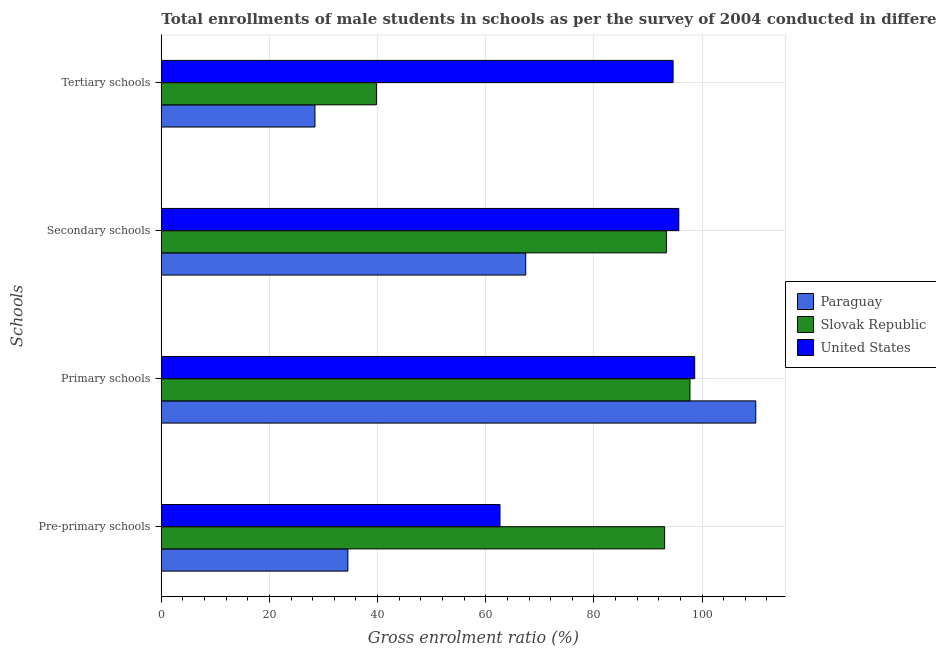How many groups of bars are there?
Offer a terse response. 4. What is the label of the 4th group of bars from the top?
Ensure brevity in your answer.  Pre-primary schools. What is the gross enrolment ratio(male) in pre-primary schools in Slovak Republic?
Your answer should be very brief. 93.08. Across all countries, what is the maximum gross enrolment ratio(male) in secondary schools?
Provide a succinct answer. 95.7. Across all countries, what is the minimum gross enrolment ratio(male) in primary schools?
Ensure brevity in your answer.  97.76. In which country was the gross enrolment ratio(male) in primary schools maximum?
Your answer should be compact. Paraguay. In which country was the gross enrolment ratio(male) in secondary schools minimum?
Make the answer very short. Paraguay. What is the total gross enrolment ratio(male) in tertiary schools in the graph?
Your response must be concise. 162.84. What is the difference between the gross enrolment ratio(male) in secondary schools in Slovak Republic and that in United States?
Keep it short and to the point. -2.29. What is the difference between the gross enrolment ratio(male) in primary schools in Slovak Republic and the gross enrolment ratio(male) in tertiary schools in Paraguay?
Provide a succinct answer. 69.35. What is the average gross enrolment ratio(male) in secondary schools per country?
Offer a very short reply. 85.5. What is the difference between the gross enrolment ratio(male) in primary schools and gross enrolment ratio(male) in secondary schools in Paraguay?
Your answer should be very brief. 42.54. In how many countries, is the gross enrolment ratio(male) in pre-primary schools greater than 48 %?
Ensure brevity in your answer.  2. What is the ratio of the gross enrolment ratio(male) in pre-primary schools in Paraguay to that in United States?
Your response must be concise. 0.55. Is the gross enrolment ratio(male) in tertiary schools in Slovak Republic less than that in United States?
Provide a short and direct response. Yes. Is the difference between the gross enrolment ratio(male) in secondary schools in Paraguay and Slovak Republic greater than the difference between the gross enrolment ratio(male) in primary schools in Paraguay and Slovak Republic?
Offer a terse response. No. What is the difference between the highest and the second highest gross enrolment ratio(male) in pre-primary schools?
Provide a short and direct response. 30.44. What is the difference between the highest and the lowest gross enrolment ratio(male) in secondary schools?
Your answer should be compact. 28.3. In how many countries, is the gross enrolment ratio(male) in secondary schools greater than the average gross enrolment ratio(male) in secondary schools taken over all countries?
Keep it short and to the point. 2. Is the sum of the gross enrolment ratio(male) in secondary schools in Paraguay and United States greater than the maximum gross enrolment ratio(male) in pre-primary schools across all countries?
Ensure brevity in your answer.  Yes. Is it the case that in every country, the sum of the gross enrolment ratio(male) in secondary schools and gross enrolment ratio(male) in tertiary schools is greater than the sum of gross enrolment ratio(male) in pre-primary schools and gross enrolment ratio(male) in primary schools?
Your answer should be compact. No. What does the 1st bar from the top in Secondary schools represents?
Ensure brevity in your answer.  United States. How many bars are there?
Provide a succinct answer. 12. Are all the bars in the graph horizontal?
Offer a terse response. Yes. How many countries are there in the graph?
Give a very brief answer. 3. Does the graph contain any zero values?
Keep it short and to the point. No. Where does the legend appear in the graph?
Give a very brief answer. Center right. What is the title of the graph?
Provide a short and direct response. Total enrollments of male students in schools as per the survey of 2004 conducted in different countries. What is the label or title of the X-axis?
Your response must be concise. Gross enrolment ratio (%). What is the label or title of the Y-axis?
Make the answer very short. Schools. What is the Gross enrolment ratio (%) in Paraguay in Pre-primary schools?
Offer a terse response. 34.5. What is the Gross enrolment ratio (%) in Slovak Republic in Pre-primary schools?
Offer a terse response. 93.08. What is the Gross enrolment ratio (%) in United States in Pre-primary schools?
Your answer should be compact. 62.63. What is the Gross enrolment ratio (%) in Paraguay in Primary schools?
Provide a short and direct response. 109.93. What is the Gross enrolment ratio (%) in Slovak Republic in Primary schools?
Your response must be concise. 97.76. What is the Gross enrolment ratio (%) of United States in Primary schools?
Offer a terse response. 98.64. What is the Gross enrolment ratio (%) in Paraguay in Secondary schools?
Your response must be concise. 67.39. What is the Gross enrolment ratio (%) in Slovak Republic in Secondary schools?
Your answer should be compact. 93.41. What is the Gross enrolment ratio (%) in United States in Secondary schools?
Make the answer very short. 95.7. What is the Gross enrolment ratio (%) of Paraguay in Tertiary schools?
Provide a short and direct response. 28.42. What is the Gross enrolment ratio (%) of Slovak Republic in Tertiary schools?
Your answer should be very brief. 39.78. What is the Gross enrolment ratio (%) of United States in Tertiary schools?
Offer a very short reply. 94.64. Across all Schools, what is the maximum Gross enrolment ratio (%) of Paraguay?
Offer a terse response. 109.93. Across all Schools, what is the maximum Gross enrolment ratio (%) of Slovak Republic?
Offer a very short reply. 97.76. Across all Schools, what is the maximum Gross enrolment ratio (%) of United States?
Provide a short and direct response. 98.64. Across all Schools, what is the minimum Gross enrolment ratio (%) of Paraguay?
Offer a terse response. 28.42. Across all Schools, what is the minimum Gross enrolment ratio (%) in Slovak Republic?
Your response must be concise. 39.78. Across all Schools, what is the minimum Gross enrolment ratio (%) in United States?
Provide a succinct answer. 62.63. What is the total Gross enrolment ratio (%) of Paraguay in the graph?
Keep it short and to the point. 240.24. What is the total Gross enrolment ratio (%) in Slovak Republic in the graph?
Offer a terse response. 324.02. What is the total Gross enrolment ratio (%) in United States in the graph?
Provide a succinct answer. 351.6. What is the difference between the Gross enrolment ratio (%) in Paraguay in Pre-primary schools and that in Primary schools?
Your response must be concise. -75.43. What is the difference between the Gross enrolment ratio (%) of Slovak Republic in Pre-primary schools and that in Primary schools?
Provide a short and direct response. -4.68. What is the difference between the Gross enrolment ratio (%) in United States in Pre-primary schools and that in Primary schools?
Provide a succinct answer. -36. What is the difference between the Gross enrolment ratio (%) of Paraguay in Pre-primary schools and that in Secondary schools?
Provide a succinct answer. -32.9. What is the difference between the Gross enrolment ratio (%) in Slovak Republic in Pre-primary schools and that in Secondary schools?
Your answer should be very brief. -0.33. What is the difference between the Gross enrolment ratio (%) in United States in Pre-primary schools and that in Secondary schools?
Keep it short and to the point. -33.06. What is the difference between the Gross enrolment ratio (%) of Paraguay in Pre-primary schools and that in Tertiary schools?
Provide a short and direct response. 6.08. What is the difference between the Gross enrolment ratio (%) of Slovak Republic in Pre-primary schools and that in Tertiary schools?
Give a very brief answer. 53.29. What is the difference between the Gross enrolment ratio (%) of United States in Pre-primary schools and that in Tertiary schools?
Ensure brevity in your answer.  -32.01. What is the difference between the Gross enrolment ratio (%) of Paraguay in Primary schools and that in Secondary schools?
Keep it short and to the point. 42.54. What is the difference between the Gross enrolment ratio (%) of Slovak Republic in Primary schools and that in Secondary schools?
Your response must be concise. 4.36. What is the difference between the Gross enrolment ratio (%) of United States in Primary schools and that in Secondary schools?
Keep it short and to the point. 2.94. What is the difference between the Gross enrolment ratio (%) in Paraguay in Primary schools and that in Tertiary schools?
Give a very brief answer. 81.52. What is the difference between the Gross enrolment ratio (%) in Slovak Republic in Primary schools and that in Tertiary schools?
Offer a terse response. 57.98. What is the difference between the Gross enrolment ratio (%) in United States in Primary schools and that in Tertiary schools?
Keep it short and to the point. 4. What is the difference between the Gross enrolment ratio (%) of Paraguay in Secondary schools and that in Tertiary schools?
Provide a short and direct response. 38.98. What is the difference between the Gross enrolment ratio (%) of Slovak Republic in Secondary schools and that in Tertiary schools?
Offer a very short reply. 53.62. What is the difference between the Gross enrolment ratio (%) in United States in Secondary schools and that in Tertiary schools?
Your answer should be compact. 1.06. What is the difference between the Gross enrolment ratio (%) in Paraguay in Pre-primary schools and the Gross enrolment ratio (%) in Slovak Republic in Primary schools?
Offer a very short reply. -63.26. What is the difference between the Gross enrolment ratio (%) of Paraguay in Pre-primary schools and the Gross enrolment ratio (%) of United States in Primary schools?
Offer a terse response. -64.14. What is the difference between the Gross enrolment ratio (%) in Slovak Republic in Pre-primary schools and the Gross enrolment ratio (%) in United States in Primary schools?
Offer a terse response. -5.56. What is the difference between the Gross enrolment ratio (%) in Paraguay in Pre-primary schools and the Gross enrolment ratio (%) in Slovak Republic in Secondary schools?
Your answer should be compact. -58.91. What is the difference between the Gross enrolment ratio (%) in Paraguay in Pre-primary schools and the Gross enrolment ratio (%) in United States in Secondary schools?
Your answer should be very brief. -61.2. What is the difference between the Gross enrolment ratio (%) in Slovak Republic in Pre-primary schools and the Gross enrolment ratio (%) in United States in Secondary schools?
Your answer should be compact. -2.62. What is the difference between the Gross enrolment ratio (%) of Paraguay in Pre-primary schools and the Gross enrolment ratio (%) of Slovak Republic in Tertiary schools?
Give a very brief answer. -5.28. What is the difference between the Gross enrolment ratio (%) in Paraguay in Pre-primary schools and the Gross enrolment ratio (%) in United States in Tertiary schools?
Your response must be concise. -60.14. What is the difference between the Gross enrolment ratio (%) in Slovak Republic in Pre-primary schools and the Gross enrolment ratio (%) in United States in Tertiary schools?
Give a very brief answer. -1.56. What is the difference between the Gross enrolment ratio (%) of Paraguay in Primary schools and the Gross enrolment ratio (%) of Slovak Republic in Secondary schools?
Provide a short and direct response. 16.53. What is the difference between the Gross enrolment ratio (%) in Paraguay in Primary schools and the Gross enrolment ratio (%) in United States in Secondary schools?
Give a very brief answer. 14.24. What is the difference between the Gross enrolment ratio (%) in Slovak Republic in Primary schools and the Gross enrolment ratio (%) in United States in Secondary schools?
Keep it short and to the point. 2.06. What is the difference between the Gross enrolment ratio (%) of Paraguay in Primary schools and the Gross enrolment ratio (%) of Slovak Republic in Tertiary schools?
Make the answer very short. 70.15. What is the difference between the Gross enrolment ratio (%) in Paraguay in Primary schools and the Gross enrolment ratio (%) in United States in Tertiary schools?
Give a very brief answer. 15.29. What is the difference between the Gross enrolment ratio (%) of Slovak Republic in Primary schools and the Gross enrolment ratio (%) of United States in Tertiary schools?
Your response must be concise. 3.12. What is the difference between the Gross enrolment ratio (%) in Paraguay in Secondary schools and the Gross enrolment ratio (%) in Slovak Republic in Tertiary schools?
Provide a succinct answer. 27.61. What is the difference between the Gross enrolment ratio (%) of Paraguay in Secondary schools and the Gross enrolment ratio (%) of United States in Tertiary schools?
Offer a very short reply. -27.25. What is the difference between the Gross enrolment ratio (%) in Slovak Republic in Secondary schools and the Gross enrolment ratio (%) in United States in Tertiary schools?
Keep it short and to the point. -1.23. What is the average Gross enrolment ratio (%) of Paraguay per Schools?
Your response must be concise. 60.06. What is the average Gross enrolment ratio (%) of Slovak Republic per Schools?
Your response must be concise. 81.01. What is the average Gross enrolment ratio (%) of United States per Schools?
Make the answer very short. 87.9. What is the difference between the Gross enrolment ratio (%) in Paraguay and Gross enrolment ratio (%) in Slovak Republic in Pre-primary schools?
Offer a very short reply. -58.58. What is the difference between the Gross enrolment ratio (%) of Paraguay and Gross enrolment ratio (%) of United States in Pre-primary schools?
Your response must be concise. -28.13. What is the difference between the Gross enrolment ratio (%) of Slovak Republic and Gross enrolment ratio (%) of United States in Pre-primary schools?
Your answer should be compact. 30.44. What is the difference between the Gross enrolment ratio (%) in Paraguay and Gross enrolment ratio (%) in Slovak Republic in Primary schools?
Offer a terse response. 12.17. What is the difference between the Gross enrolment ratio (%) in Paraguay and Gross enrolment ratio (%) in United States in Primary schools?
Your answer should be compact. 11.3. What is the difference between the Gross enrolment ratio (%) of Slovak Republic and Gross enrolment ratio (%) of United States in Primary schools?
Offer a very short reply. -0.87. What is the difference between the Gross enrolment ratio (%) in Paraguay and Gross enrolment ratio (%) in Slovak Republic in Secondary schools?
Give a very brief answer. -26.01. What is the difference between the Gross enrolment ratio (%) of Paraguay and Gross enrolment ratio (%) of United States in Secondary schools?
Ensure brevity in your answer.  -28.3. What is the difference between the Gross enrolment ratio (%) in Slovak Republic and Gross enrolment ratio (%) in United States in Secondary schools?
Your answer should be very brief. -2.29. What is the difference between the Gross enrolment ratio (%) of Paraguay and Gross enrolment ratio (%) of Slovak Republic in Tertiary schools?
Provide a short and direct response. -11.37. What is the difference between the Gross enrolment ratio (%) of Paraguay and Gross enrolment ratio (%) of United States in Tertiary schools?
Your response must be concise. -66.22. What is the difference between the Gross enrolment ratio (%) in Slovak Republic and Gross enrolment ratio (%) in United States in Tertiary schools?
Provide a short and direct response. -54.86. What is the ratio of the Gross enrolment ratio (%) of Paraguay in Pre-primary schools to that in Primary schools?
Your answer should be very brief. 0.31. What is the ratio of the Gross enrolment ratio (%) of Slovak Republic in Pre-primary schools to that in Primary schools?
Offer a terse response. 0.95. What is the ratio of the Gross enrolment ratio (%) in United States in Pre-primary schools to that in Primary schools?
Offer a terse response. 0.64. What is the ratio of the Gross enrolment ratio (%) in Paraguay in Pre-primary schools to that in Secondary schools?
Offer a very short reply. 0.51. What is the ratio of the Gross enrolment ratio (%) of United States in Pre-primary schools to that in Secondary schools?
Offer a terse response. 0.65. What is the ratio of the Gross enrolment ratio (%) of Paraguay in Pre-primary schools to that in Tertiary schools?
Provide a succinct answer. 1.21. What is the ratio of the Gross enrolment ratio (%) in Slovak Republic in Pre-primary schools to that in Tertiary schools?
Your answer should be very brief. 2.34. What is the ratio of the Gross enrolment ratio (%) of United States in Pre-primary schools to that in Tertiary schools?
Your answer should be very brief. 0.66. What is the ratio of the Gross enrolment ratio (%) of Paraguay in Primary schools to that in Secondary schools?
Provide a short and direct response. 1.63. What is the ratio of the Gross enrolment ratio (%) in Slovak Republic in Primary schools to that in Secondary schools?
Offer a terse response. 1.05. What is the ratio of the Gross enrolment ratio (%) in United States in Primary schools to that in Secondary schools?
Your answer should be very brief. 1.03. What is the ratio of the Gross enrolment ratio (%) in Paraguay in Primary schools to that in Tertiary schools?
Offer a very short reply. 3.87. What is the ratio of the Gross enrolment ratio (%) in Slovak Republic in Primary schools to that in Tertiary schools?
Ensure brevity in your answer.  2.46. What is the ratio of the Gross enrolment ratio (%) of United States in Primary schools to that in Tertiary schools?
Keep it short and to the point. 1.04. What is the ratio of the Gross enrolment ratio (%) of Paraguay in Secondary schools to that in Tertiary schools?
Your answer should be very brief. 2.37. What is the ratio of the Gross enrolment ratio (%) of Slovak Republic in Secondary schools to that in Tertiary schools?
Ensure brevity in your answer.  2.35. What is the ratio of the Gross enrolment ratio (%) in United States in Secondary schools to that in Tertiary schools?
Provide a short and direct response. 1.01. What is the difference between the highest and the second highest Gross enrolment ratio (%) of Paraguay?
Provide a short and direct response. 42.54. What is the difference between the highest and the second highest Gross enrolment ratio (%) of Slovak Republic?
Your answer should be very brief. 4.36. What is the difference between the highest and the second highest Gross enrolment ratio (%) in United States?
Offer a terse response. 2.94. What is the difference between the highest and the lowest Gross enrolment ratio (%) in Paraguay?
Your response must be concise. 81.52. What is the difference between the highest and the lowest Gross enrolment ratio (%) in Slovak Republic?
Offer a terse response. 57.98. What is the difference between the highest and the lowest Gross enrolment ratio (%) of United States?
Provide a succinct answer. 36. 